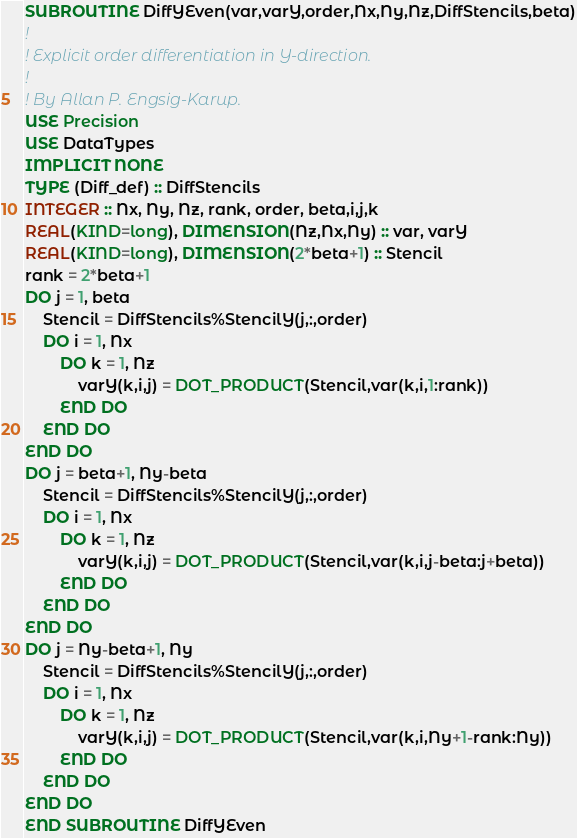Convert code to text. <code><loc_0><loc_0><loc_500><loc_500><_FORTRAN_>SUBROUTINE DiffYEven(var,varY,order,Nx,Ny,Nz,DiffStencils,beta)
!
! Explicit order differentiation in Y-direction.
!
! By Allan P. Engsig-Karup.
USE Precision
USE DataTypes
IMPLICIT NONE
TYPE (Diff_def) :: DiffStencils
INTEGER :: Nx, Ny, Nz, rank, order, beta,i,j,k
REAL(KIND=long), DIMENSION(Nz,Nx,Ny) :: var, varY
REAL(KIND=long), DIMENSION(2*beta+1) :: Stencil
rank = 2*beta+1
DO j = 1, beta
	Stencil = DiffStencils%StencilY(j,:,order)
	DO i = 1, Nx
		DO k = 1, Nz
			varY(k,i,j) = DOT_PRODUCT(Stencil,var(k,i,1:rank))
		END DO
	END DO
END DO
DO j = beta+1, Ny-beta
	Stencil = DiffStencils%StencilY(j,:,order)
	DO i = 1, Nx
		DO k = 1, Nz
			varY(k,i,j) = DOT_PRODUCT(Stencil,var(k,i,j-beta:j+beta))
		END DO
	END DO
END DO
DO j = Ny-beta+1, Ny
	Stencil = DiffStencils%StencilY(j,:,order)
	DO i = 1, Nx
		DO k = 1, Nz
			varY(k,i,j) = DOT_PRODUCT(Stencil,var(k,i,Ny+1-rank:Ny))
		END DO
	END DO
END DO
END SUBROUTINE DiffYEven
</code> 